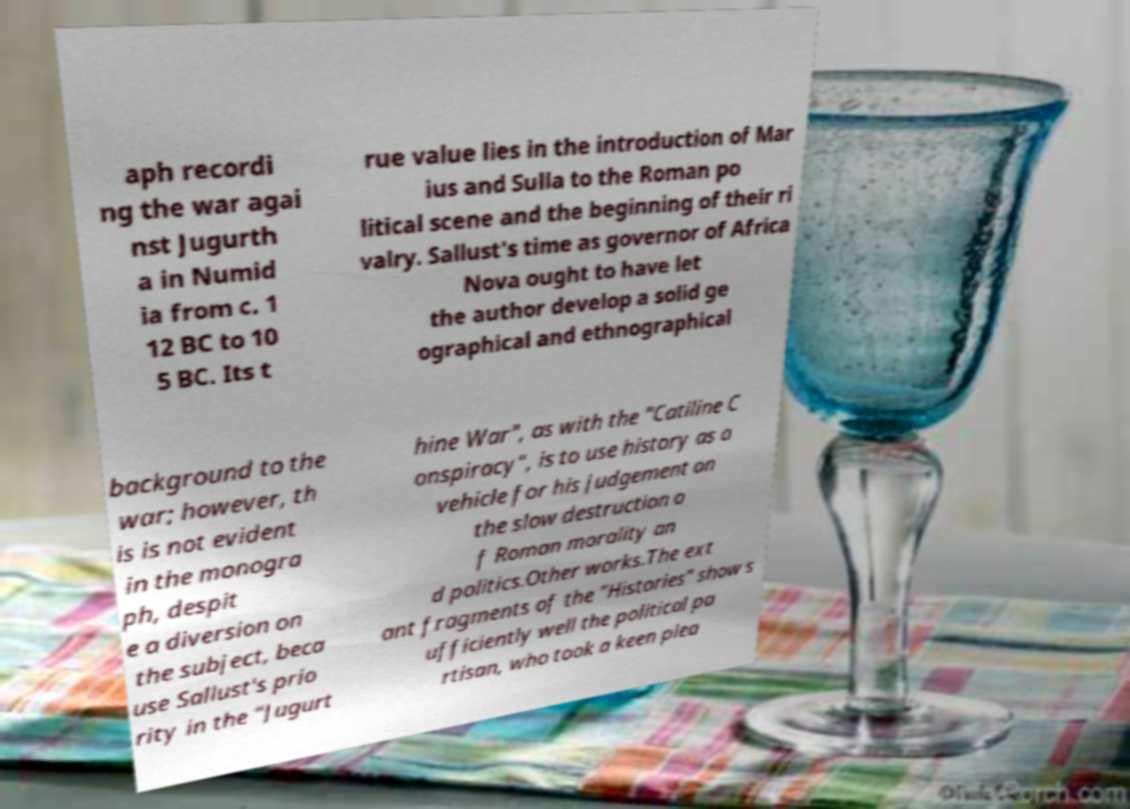What messages or text are displayed in this image? I need them in a readable, typed format. aph recordi ng the war agai nst Jugurth a in Numid ia from c. 1 12 BC to 10 5 BC. Its t rue value lies in the introduction of Mar ius and Sulla to the Roman po litical scene and the beginning of their ri valry. Sallust's time as governor of Africa Nova ought to have let the author develop a solid ge ographical and ethnographical background to the war; however, th is is not evident in the monogra ph, despit e a diversion on the subject, beca use Sallust's prio rity in the "Jugurt hine War", as with the "Catiline C onspiracy", is to use history as a vehicle for his judgement on the slow destruction o f Roman morality an d politics.Other works.The ext ant fragments of the "Histories" show s ufficiently well the political pa rtisan, who took a keen plea 